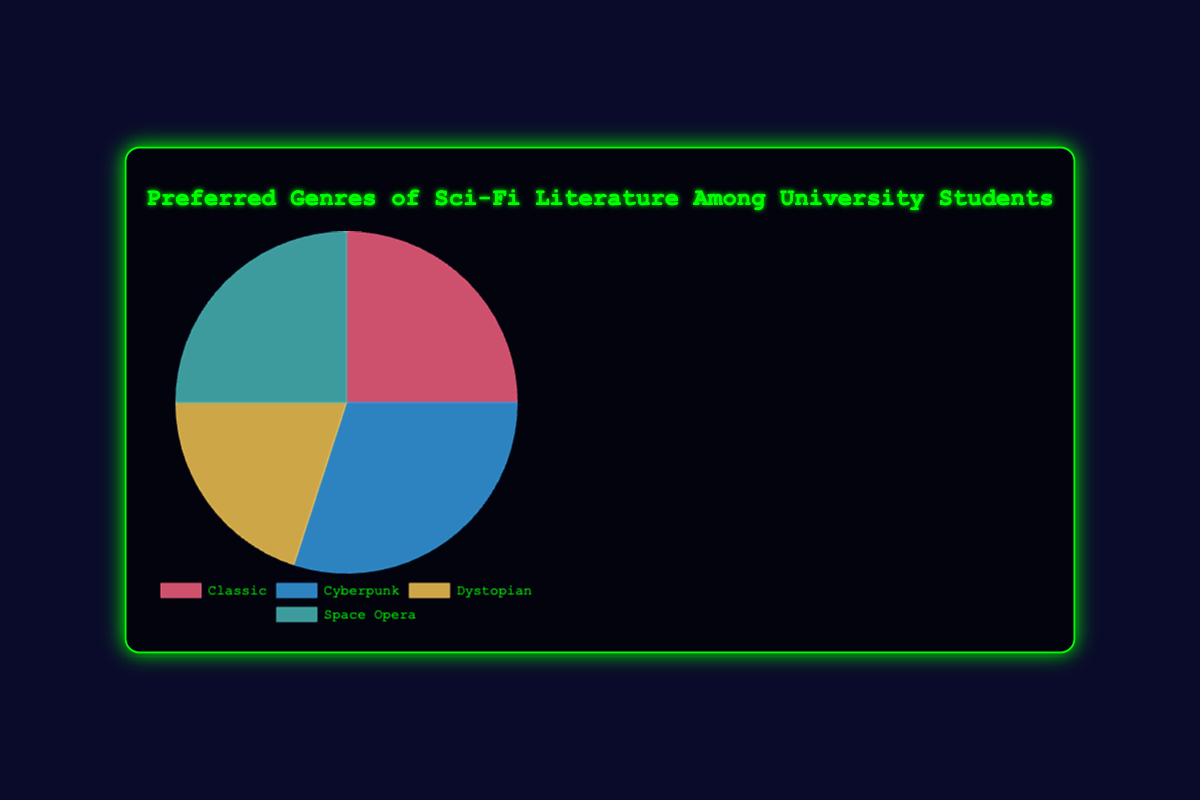Which genre has the highest preference among university students? The pie chart shows that "Cyberpunk" has the highest preference, with 30%.
Answer: Cyberpunk What percentage of students prefer Classic and Space Opera combined? The preferences for Classic and Space Opera are 25% each. Adding these together gives 25% + 25% = 50%.
Answer: 50% How much more popular is Cyberpunk compared to Dystopian? Cyberpunk has 30% preference, and Dystopian has 20%. Subtracting the two gives 30% - 20% = 10%.
Answer: 10% Are Classic and Dystopian preferred equally? The pie chart shows Classic with 25% and Dystopian with 20%, so they are not preferred equally.
Answer: No Which genre is preferred by the same percentage of students as Classic? The pie chart shows that both Classic and Space Opera have a 25% preference among students.
Answer: Space Opera What is the average preference percentage for all four genres? The four percentages are 25%, 30%, 20%, and 25%. Adding them gives 25 + 30 + 20 + 25 = 100%. Dividing by 4 gives 100 / 4 = 25%.
Answer: 25% Which genre has the lowest preference, and what is the percentage? The pie chart shows that Dystopian has the lowest preference at 20%.
Answer: Dystopian, 20% What is the difference in percentage between the highest and lowest preferred genres? Cyberpunk is the highest at 30%, while Dystopian is the lowest at 20%. The difference is 30% - 20% = 10%.
Answer: 10% Which genres combined make up half of the total preferences? Classic and Space Opera together make up 25% + 25% = 50%, which is half of the total preferences.
Answer: Classic and Space Opera 